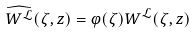Convert formula to latex. <formula><loc_0><loc_0><loc_500><loc_500>\widehat { W ^ { \mathcal { L } } } ( \zeta , z ) = \varphi ( \zeta ) W ^ { \mathcal { L } } ( \zeta , z )</formula> 